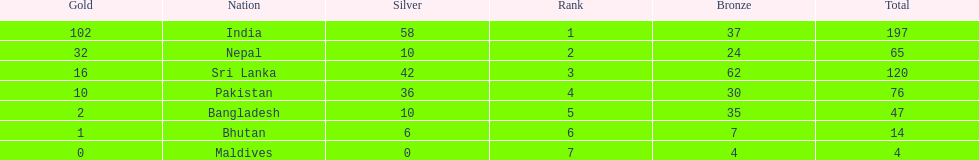How many gold medals were awarded between all 7 nations? 163. 